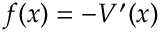<formula> <loc_0><loc_0><loc_500><loc_500>f ( x ) = - V ^ { \prime } ( x )</formula> 